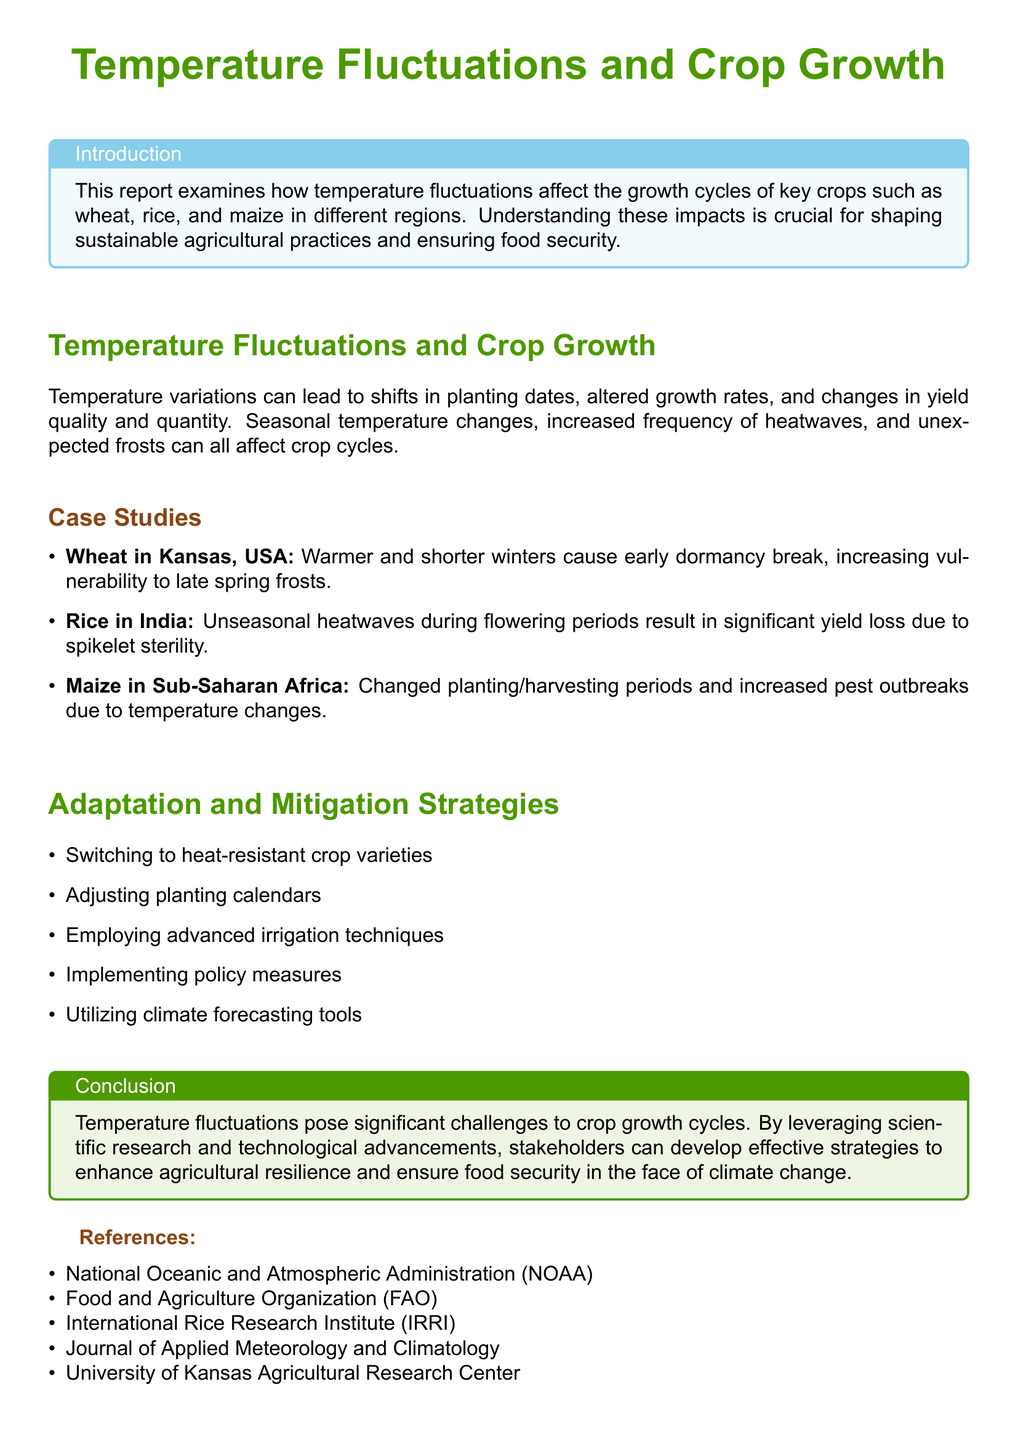What is the focus of the report? The report examines how temperature fluctuations affect the growth cycles of key crops in different regions.
Answer: Temperature fluctuations and crop growth What crop is affected by unseasonal heatwaves in India? The report mentions rice as being affected by unseasonal heatwaves during flowering periods.
Answer: Rice Which region faces challenges with maize due to temperature changes? The report specifies Sub-Saharan Africa in relation to maize temperature challenges.
Answer: Sub-Saharan Africa What adaptation strategy involves changing the timing of planting? Adjusting planting calendars is one of the adaptation strategies mentioned.
Answer: Adjusting planting calendars What specific vulnerability does wheat in Kansas face? The report states that wheat in Kansas experiences increased vulnerability to late spring frosts.
Answer: Increased vulnerability to late spring frosts How do temperature fluctuations impact crop yields? Temperature fluctuations can lead to changes in yield quality and quantity.
Answer: Changes in yield quality and quantity What is one of the advanced irrigation techniques suggested? The report discusses employing advanced irrigation techniques as a strategy.
Answer: Advanced irrigation techniques Which organization is not listed as a reference? The report provides specific references, but one organization not mentioned is the National Agricultural Statistics Service (NASS).
Answer: National Agricultural Statistics Service (NASS) What is the primary concern regarding temperature fluctuations and agriculture? The conclusion indicates that temperature fluctuations pose significant challenges to crop growth cycles.
Answer: Significant challenges to crop growth cycles 